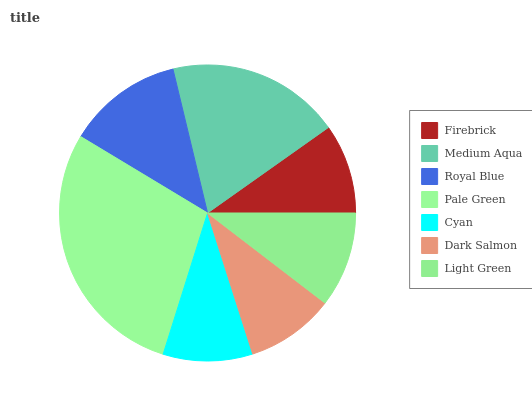Is Dark Salmon the minimum?
Answer yes or no. Yes. Is Pale Green the maximum?
Answer yes or no. Yes. Is Medium Aqua the minimum?
Answer yes or no. No. Is Medium Aqua the maximum?
Answer yes or no. No. Is Medium Aqua greater than Firebrick?
Answer yes or no. Yes. Is Firebrick less than Medium Aqua?
Answer yes or no. Yes. Is Firebrick greater than Medium Aqua?
Answer yes or no. No. Is Medium Aqua less than Firebrick?
Answer yes or no. No. Is Light Green the high median?
Answer yes or no. Yes. Is Light Green the low median?
Answer yes or no. Yes. Is Cyan the high median?
Answer yes or no. No. Is Royal Blue the low median?
Answer yes or no. No. 